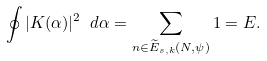<formula> <loc_0><loc_0><loc_500><loc_500>\oint | K ( \alpha ) | ^ { 2 } \ d \alpha = \sum _ { n \in \widetilde { E } _ { s , k } ( N , \psi ) } 1 = E .</formula> 